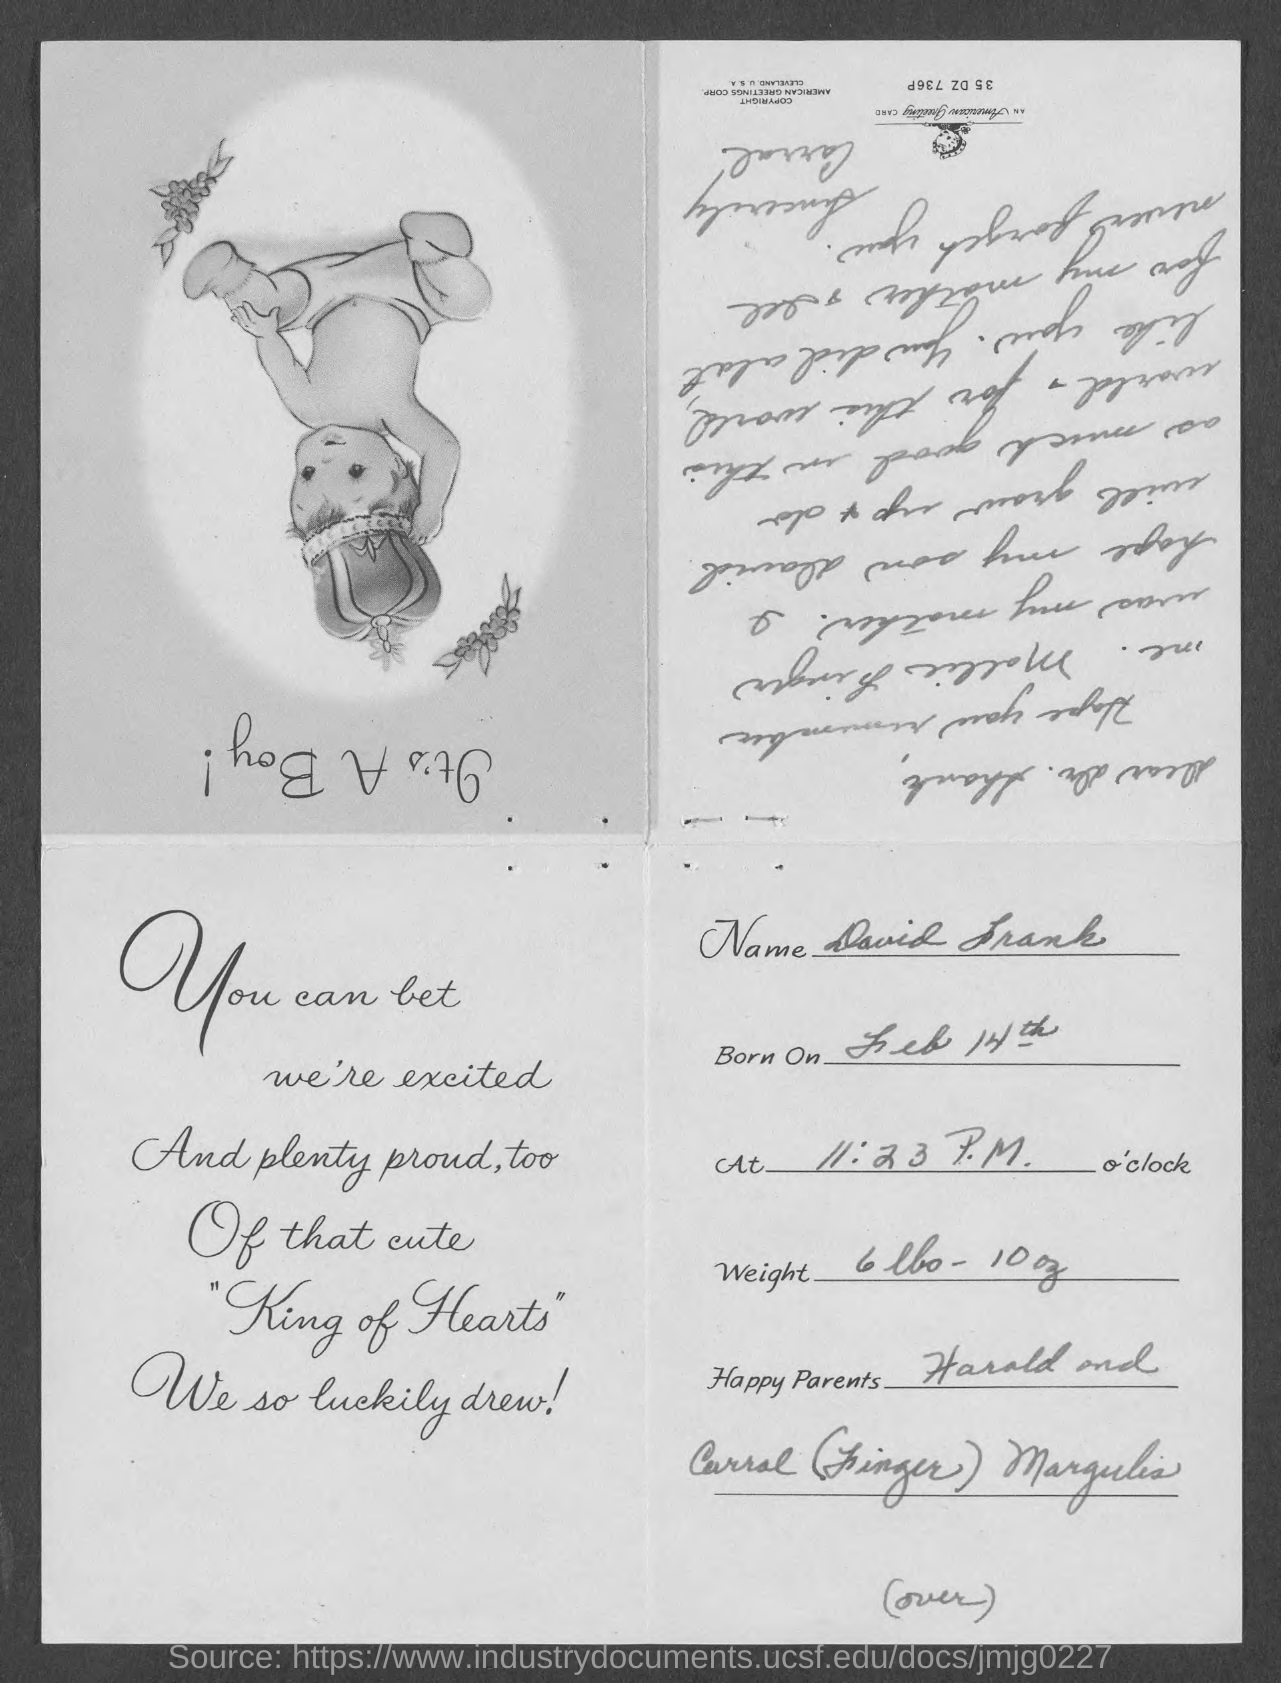What is the Name?
Your response must be concise. David Frank. When is he born on?
Offer a very short reply. Feb 14th. What time is he born on?
Provide a succinct answer. 11:23 P.M. What is the Weight?
Ensure brevity in your answer.  6lbs - 10oz. 